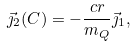<formula> <loc_0><loc_0><loc_500><loc_500>\vec { \jmath } _ { 2 } ( C ) = - \frac { c r } { m _ { Q } } \vec { \jmath } _ { 1 } ,</formula> 